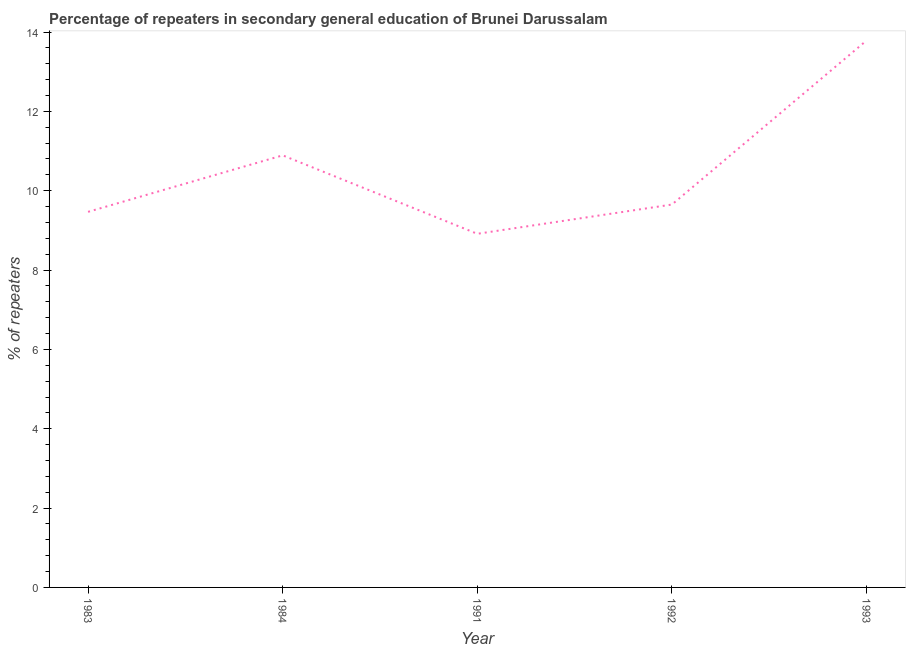What is the percentage of repeaters in 1983?
Make the answer very short. 9.47. Across all years, what is the maximum percentage of repeaters?
Make the answer very short. 13.79. Across all years, what is the minimum percentage of repeaters?
Your answer should be compact. 8.91. In which year was the percentage of repeaters maximum?
Give a very brief answer. 1993. In which year was the percentage of repeaters minimum?
Keep it short and to the point. 1991. What is the sum of the percentage of repeaters?
Keep it short and to the point. 52.71. What is the difference between the percentage of repeaters in 1991 and 1993?
Provide a short and direct response. -4.87. What is the average percentage of repeaters per year?
Provide a succinct answer. 10.54. What is the median percentage of repeaters?
Your response must be concise. 9.65. In how many years, is the percentage of repeaters greater than 3.6 %?
Ensure brevity in your answer.  5. What is the ratio of the percentage of repeaters in 1983 to that in 1991?
Your answer should be very brief. 1.06. What is the difference between the highest and the second highest percentage of repeaters?
Provide a short and direct response. 2.9. What is the difference between the highest and the lowest percentage of repeaters?
Make the answer very short. 4.87. In how many years, is the percentage of repeaters greater than the average percentage of repeaters taken over all years?
Provide a succinct answer. 2. How many lines are there?
Make the answer very short. 1. What is the difference between two consecutive major ticks on the Y-axis?
Offer a very short reply. 2. Are the values on the major ticks of Y-axis written in scientific E-notation?
Provide a succinct answer. No. Does the graph contain grids?
Your answer should be compact. No. What is the title of the graph?
Keep it short and to the point. Percentage of repeaters in secondary general education of Brunei Darussalam. What is the label or title of the X-axis?
Ensure brevity in your answer.  Year. What is the label or title of the Y-axis?
Make the answer very short. % of repeaters. What is the % of repeaters in 1983?
Make the answer very short. 9.47. What is the % of repeaters of 1984?
Offer a terse response. 10.89. What is the % of repeaters of 1991?
Your answer should be compact. 8.91. What is the % of repeaters of 1992?
Ensure brevity in your answer.  9.65. What is the % of repeaters of 1993?
Offer a terse response. 13.79. What is the difference between the % of repeaters in 1983 and 1984?
Ensure brevity in your answer.  -1.42. What is the difference between the % of repeaters in 1983 and 1991?
Your answer should be very brief. 0.55. What is the difference between the % of repeaters in 1983 and 1992?
Your response must be concise. -0.18. What is the difference between the % of repeaters in 1983 and 1993?
Your answer should be very brief. -4.32. What is the difference between the % of repeaters in 1984 and 1991?
Provide a short and direct response. 1.98. What is the difference between the % of repeaters in 1984 and 1992?
Your answer should be compact. 1.24. What is the difference between the % of repeaters in 1984 and 1993?
Your answer should be compact. -2.9. What is the difference between the % of repeaters in 1991 and 1992?
Provide a succinct answer. -0.74. What is the difference between the % of repeaters in 1991 and 1993?
Keep it short and to the point. -4.87. What is the difference between the % of repeaters in 1992 and 1993?
Give a very brief answer. -4.14. What is the ratio of the % of repeaters in 1983 to that in 1984?
Your answer should be compact. 0.87. What is the ratio of the % of repeaters in 1983 to that in 1991?
Your response must be concise. 1.06. What is the ratio of the % of repeaters in 1983 to that in 1992?
Make the answer very short. 0.98. What is the ratio of the % of repeaters in 1983 to that in 1993?
Provide a succinct answer. 0.69. What is the ratio of the % of repeaters in 1984 to that in 1991?
Ensure brevity in your answer.  1.22. What is the ratio of the % of repeaters in 1984 to that in 1992?
Offer a terse response. 1.13. What is the ratio of the % of repeaters in 1984 to that in 1993?
Your response must be concise. 0.79. What is the ratio of the % of repeaters in 1991 to that in 1992?
Offer a very short reply. 0.92. What is the ratio of the % of repeaters in 1991 to that in 1993?
Your response must be concise. 0.65. 